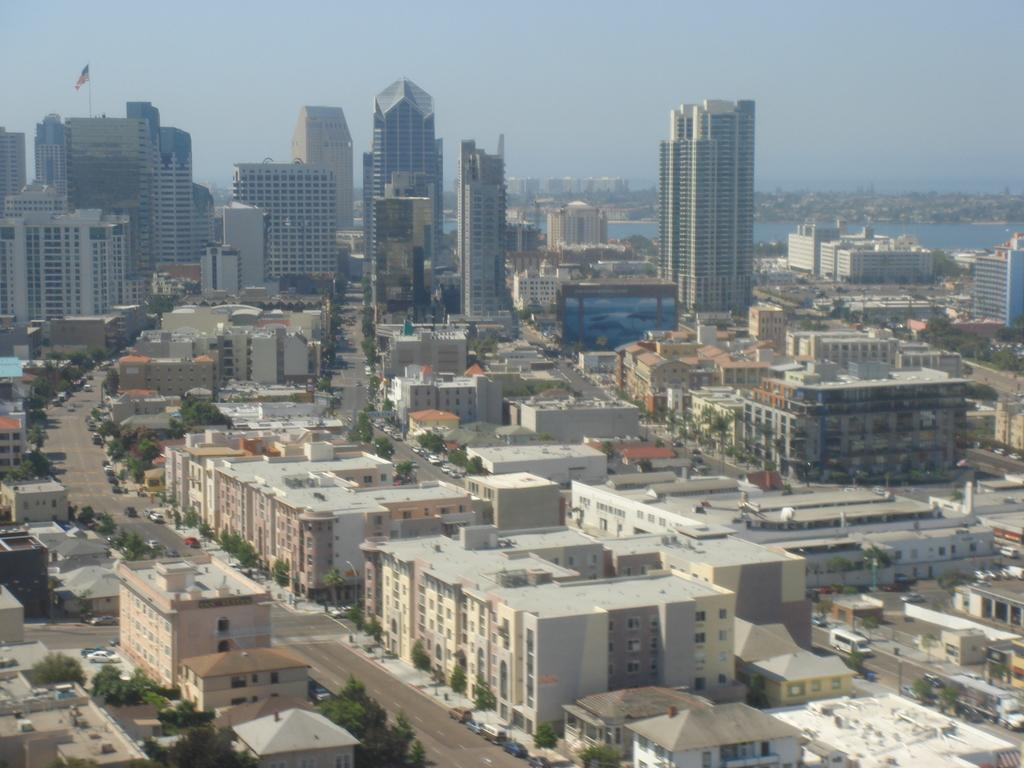What type of structures can be seen in the image? There are buildings in the image. What natural elements are present in the image? There are trees in the image. What type of transportation is visible on the road in the image? There are vehicles on the road in the image. What symbol can be seen in the image? There is a flag in the image. What body of water is visible in the image? There is water visible in the image. What part of the natural environment is visible in the image? The sky is visible in the image. What type of muscle is being exercised by the porter in the image? There is no porter present in the image, and therefore no muscle exercise can be observed. What scientific experiment is being conducted in the image? There is no scientific experiment present in the image. 